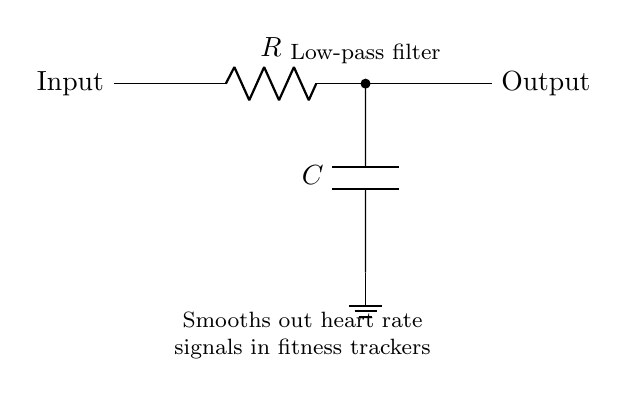What components are in this circuit? The circuit includes a resistor and a capacitor, which are the key components of a low-pass filter. The resistor is at the top of the diagram, and the capacitor is below it, connecting to ground.
Answer: resistor, capacitor What does this circuit do? This circuit smooths out heart rate signals from fitness trackers, as indicated by the annotation below the circuit diagram. The purpose is to filter out high-frequency noise and allow low-frequency signals to pass through, providing a clearer heart rate signal.
Answer: smooths heart rate signals What is the configuration of components in this low-pass filter? The configuration consists of a resistor in series with a capacitor connected to ground. The input signal goes through the resistor first, then to the capacitor, which is the defining feature of a low-pass filter.
Answer: resistor in series with capacitor What is the output of the circuit? The output is taken from the node between the resistor and the capacitor, where the smoothed signal appears. This output provides the processed signal to the next stage of the fitness tracker system.
Answer: smoothed signal How does increasing the resistance affect this filter? Increasing the resistance will lower the cutoff frequency of the filter, allowing fewer high-frequency signals to pass. The relationship between resistance, capacitance, and cutoff frequency can be derived from the formula for the cutoff frequency of a low-pass filter.
Answer: lowers cutoff frequency What does the ground symbol signify in this circuit? The ground symbol indicates a reference point for voltage, typically representing zero volts. It serves as the return path for current flow and is essential for ensuring that the circuit functions correctly and provides stable operation.
Answer: reference point for voltage What is the function of the capacitor in this circuit? The capacitor stores and releases charge, which helps to smooth out changes in voltage. In a low-pass filter, it allows low-frequency signals to pass while filtering out rapid changes, effectively stabilizing the output signal.
Answer: smooth out changes in voltage 